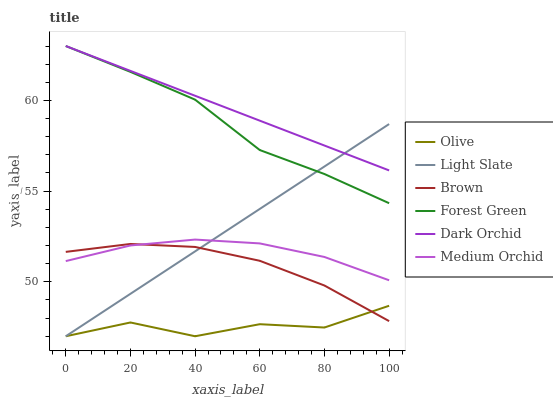Does Light Slate have the minimum area under the curve?
Answer yes or no. No. Does Light Slate have the maximum area under the curve?
Answer yes or no. No. Is Medium Orchid the smoothest?
Answer yes or no. No. Is Medium Orchid the roughest?
Answer yes or no. No. Does Medium Orchid have the lowest value?
Answer yes or no. No. Does Light Slate have the highest value?
Answer yes or no. No. Is Medium Orchid less than Dark Orchid?
Answer yes or no. Yes. Is Dark Orchid greater than Medium Orchid?
Answer yes or no. Yes. Does Medium Orchid intersect Dark Orchid?
Answer yes or no. No. 